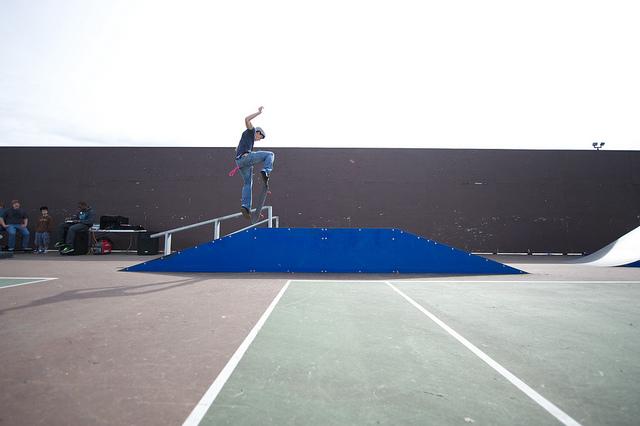What color is the ramp?
Be succinct. Blue. Is this a demo?
Write a very short answer. No. What is the man doing?
Write a very short answer. Skateboarding. 